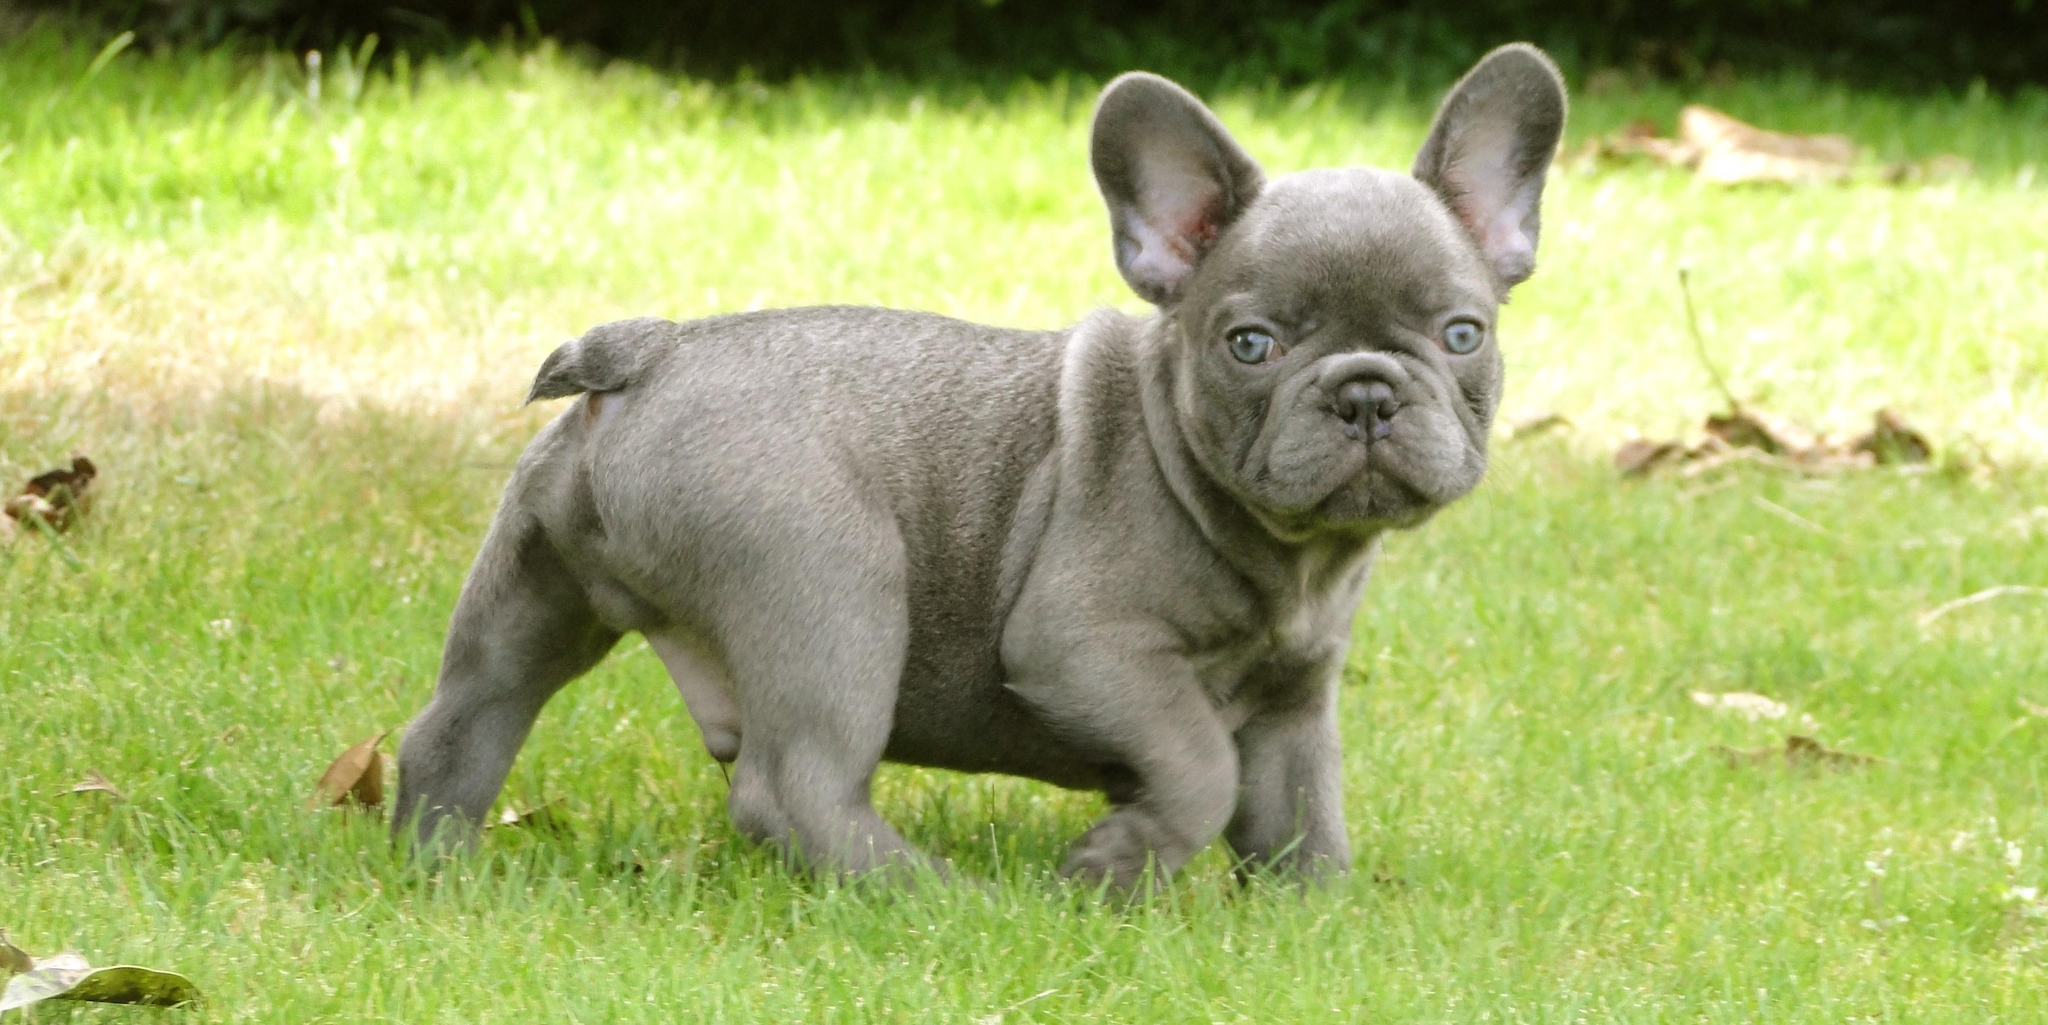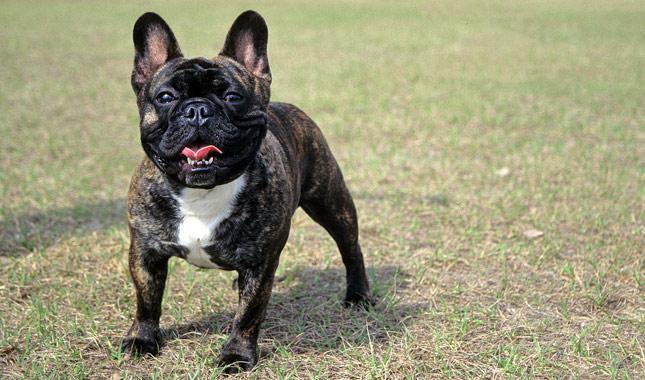The first image is the image on the left, the second image is the image on the right. For the images displayed, is the sentence "Both dogs are looking at the camera." factually correct? Answer yes or no. Yes. The first image is the image on the left, the second image is the image on the right. Examine the images to the left and right. Is the description "One of the dogs has blue eyes." accurate? Answer yes or no. Yes. 